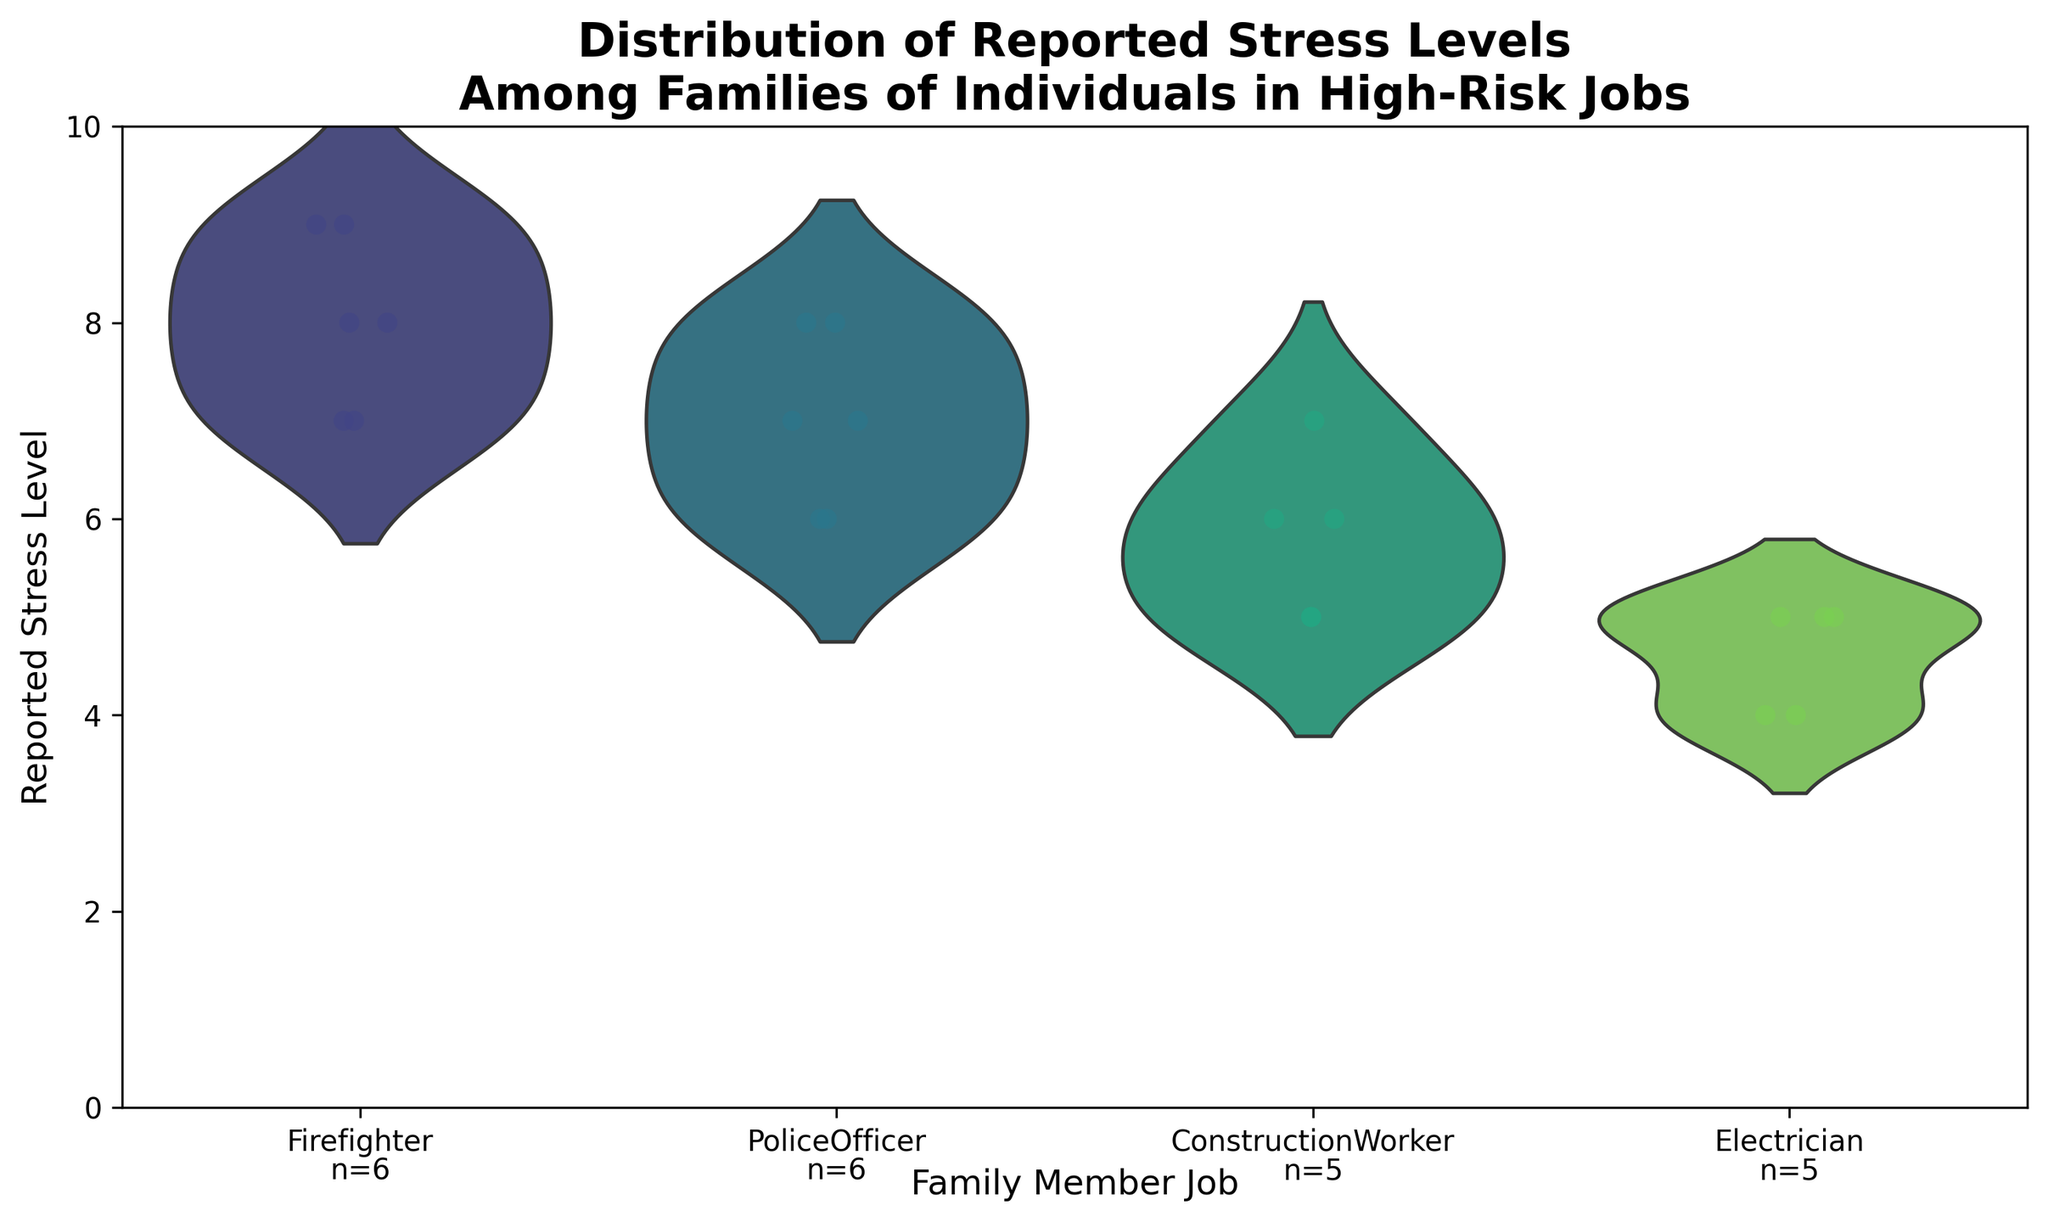What is the title of the figure? The title of the figure is written at the top of the chart.
Answer: Distribution of Reported Stress Levels Among Families of Individuals in High-Risk Jobs Which job has the highest reported stress level? The jitters (points) for Firefighters, on average, appear to be higher than other jobs.
Answer: Firefighter How many data points are there for each job? The text at the bottom of each job's violin shows the count.
Answer: Firefighter: 5, PoliceOfficer: 5, ConstructionWorker: 5, Electrician: 4 What is the lowest reported stress level for Electricians? The lowest reported level for Electricians is the lowest jitter point for them in the plot.
Answer: 4 Which job has the widest spread of reported stress levels? The widest spread can be observed by looking at the violin plot's height.
Answer: Firefighter What's the range of the reported stress levels for Police Officers? Subtract the minimum stress level from the maximum stress level for Police Officers.
Answer: 8 - 6 = 2 Are there any jobs with the same minimum and maximum stress levels? This can be observed by checking if any violin plots have only one height.
Answer: No What color palette is used in the figure? The palette is a visual cue used for colors in the violin and jittered points.
Answer: Viridis Which job has the most consistent (least variable) reported stress levels? The job with the tightest spread of jitters and narrowest violin has the least variability.
Answer: Electrician What is the median reported stress level for Construction Workers? The median can be estimated by looking at where the middle bulk of the points are distributed.
Answer: 6 